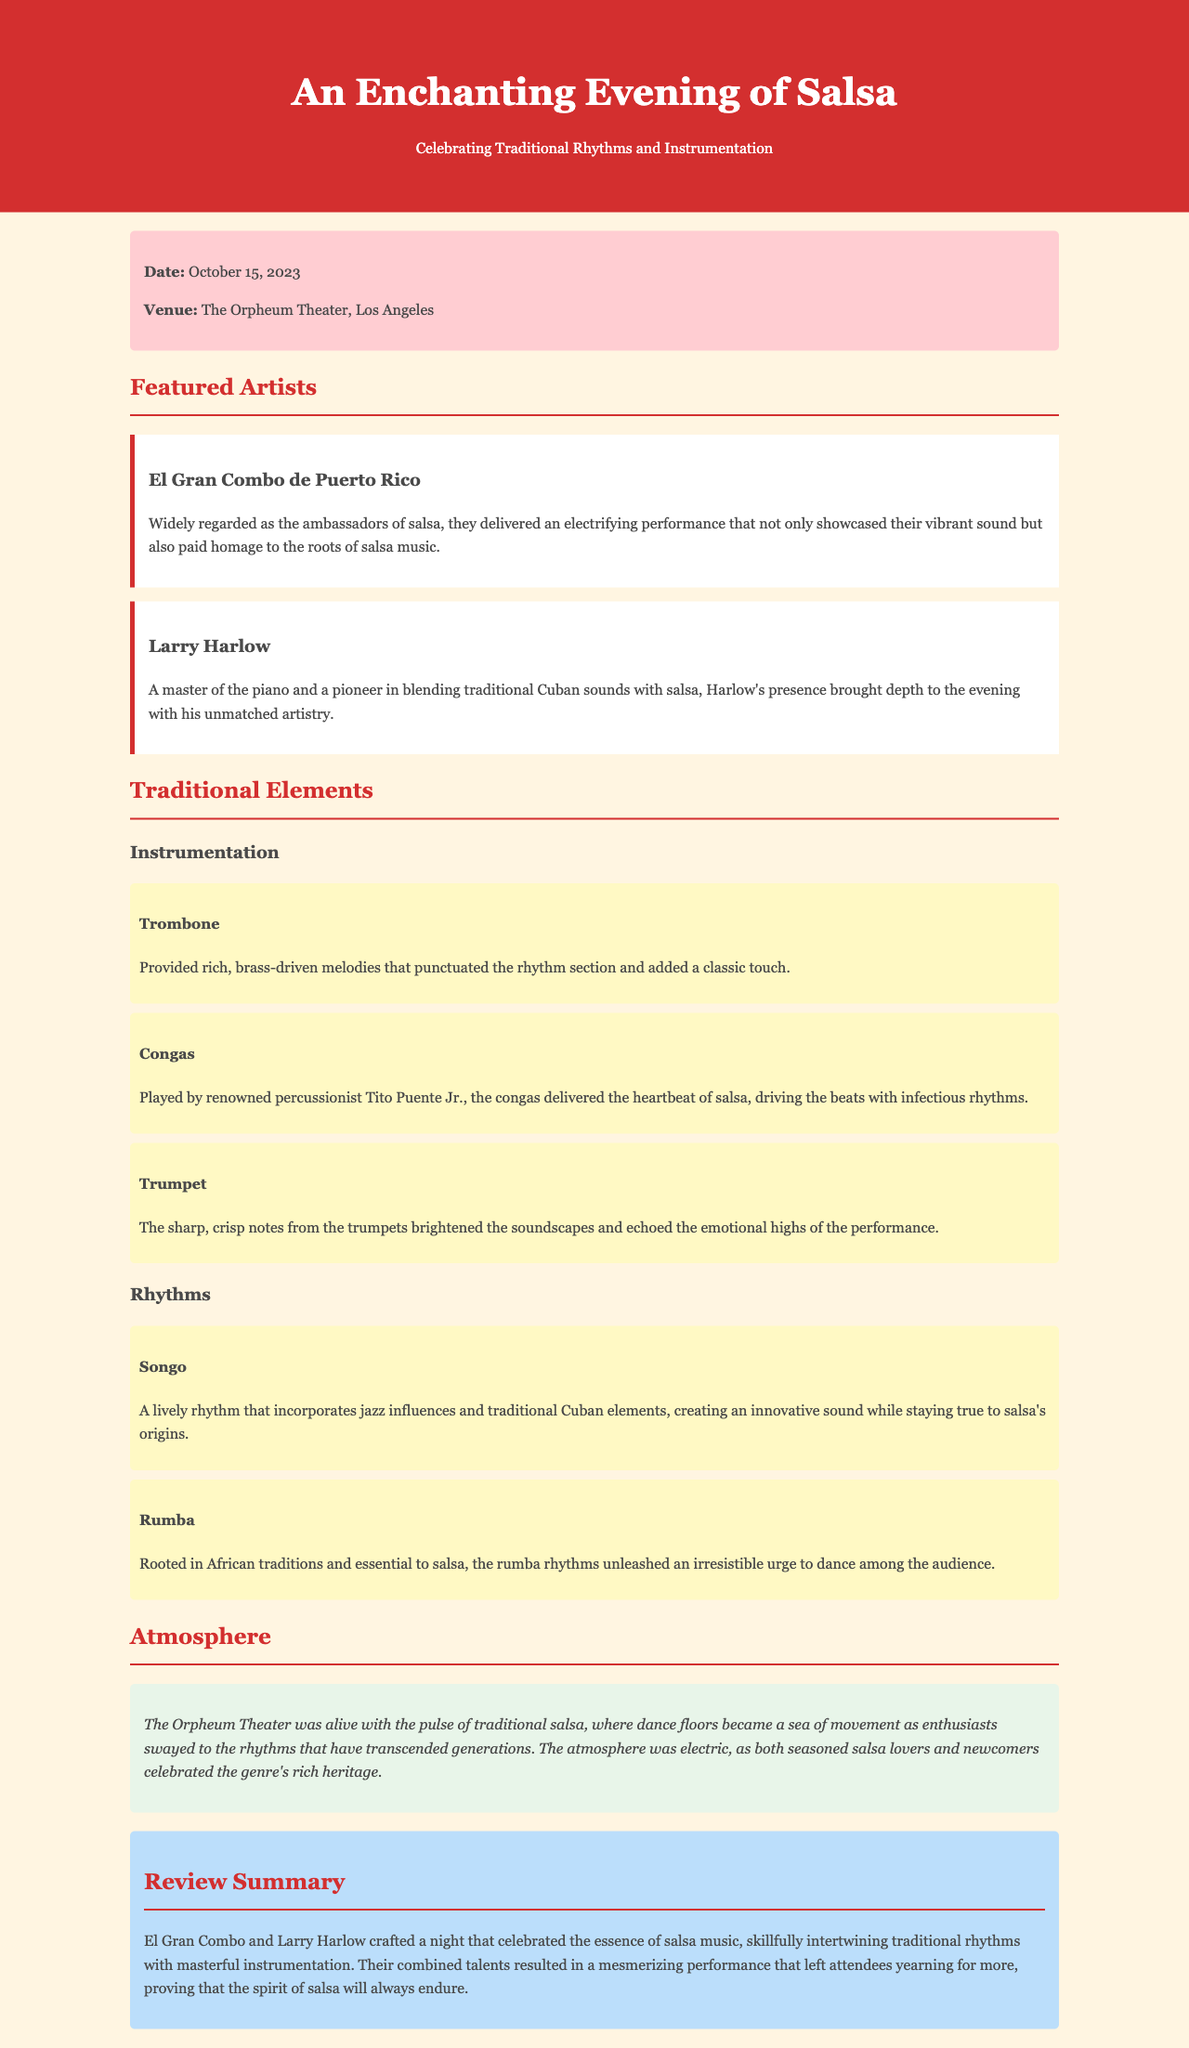What is the date of the concert? The date is specifically mentioned in the event info section of the document.
Answer: October 15, 2023 Where was the concert held? The venue is also provided in the event info section of the document.
Answer: The Orpheum Theater, Los Angeles Who is the renowned percussionist mentioned? The document specifically names a percussionist in relation to the congas.
Answer: Tito Puente Jr What element does the trombone provide? The document describes the role of the trombone in the instrumentation section.
Answer: Rich, brass-driven melodies Which rhythm is rooted in African traditions? The document identifies specific rhythms and their cultural origins.
Answer: Rumba What type of music did Larry Harlow blend with salsa? The document highlights Larry Harlow's musical contributions.
Answer: Traditional Cuban sounds What atmosphere was prevalent during the concert? The atmosphere description provides insight into the event's vibe.
Answer: Electric What did El Gran Combo and Larry Harlow showcase? The review summary explains the focus of their performance.
Answer: The essence of salsa music 